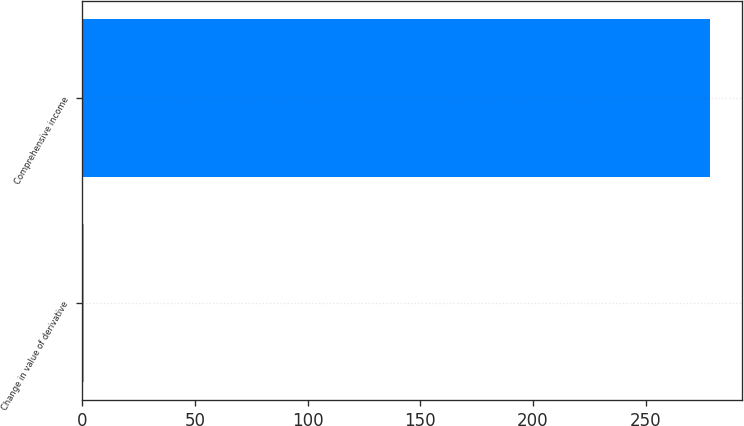Convert chart to OTSL. <chart><loc_0><loc_0><loc_500><loc_500><bar_chart><fcel>Change in value of derivative<fcel>Comprehensive income<nl><fcel>1<fcel>278.6<nl></chart> 